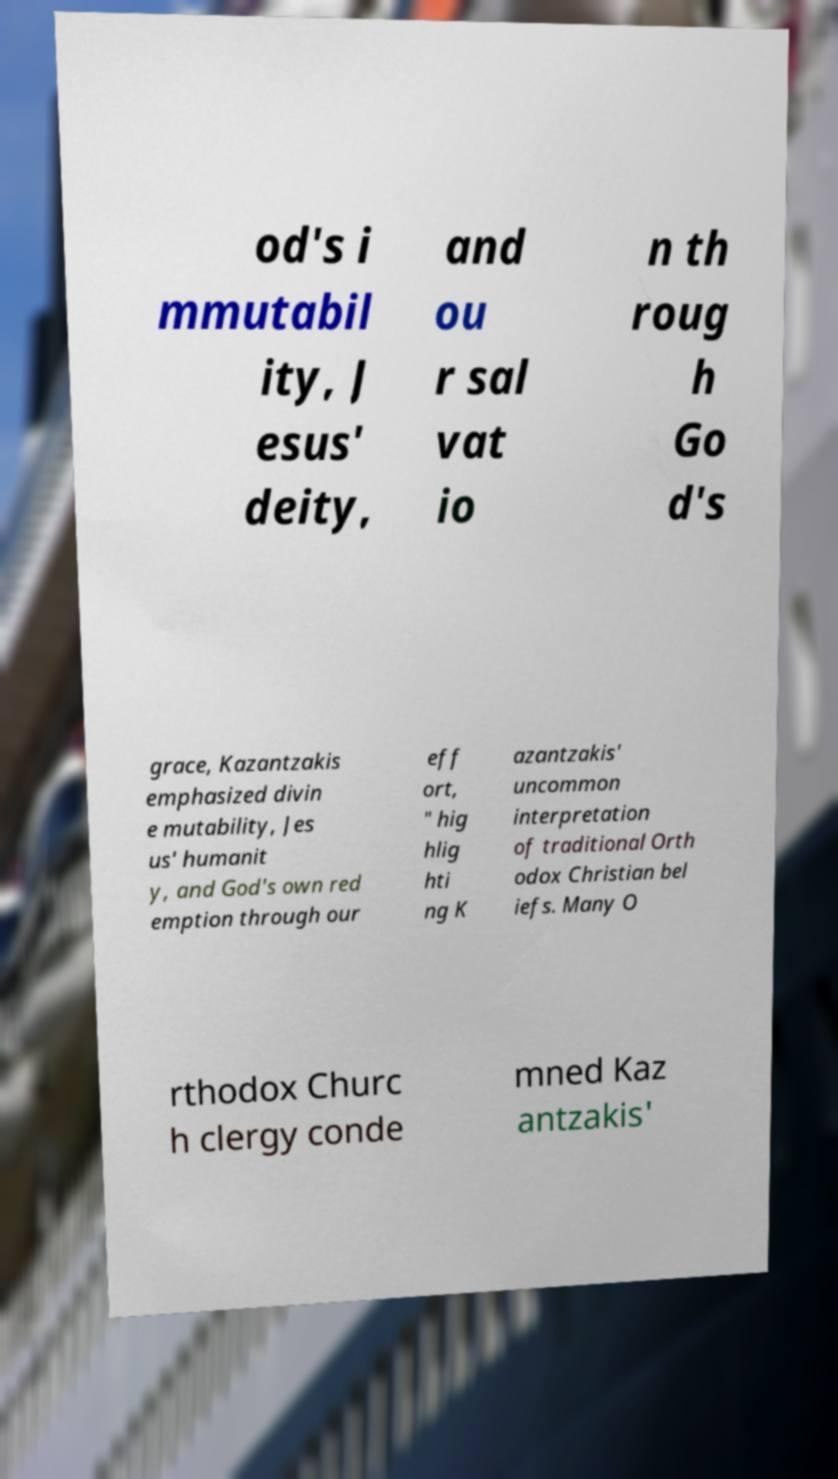There's text embedded in this image that I need extracted. Can you transcribe it verbatim? od's i mmutabil ity, J esus' deity, and ou r sal vat io n th roug h Go d's grace, Kazantzakis emphasized divin e mutability, Jes us' humanit y, and God's own red emption through our eff ort, " hig hlig hti ng K azantzakis' uncommon interpretation of traditional Orth odox Christian bel iefs. Many O rthodox Churc h clergy conde mned Kaz antzakis' 